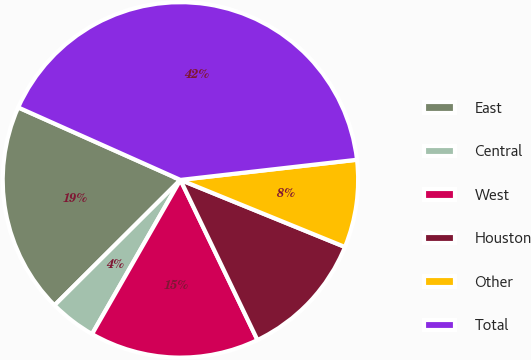<chart> <loc_0><loc_0><loc_500><loc_500><pie_chart><fcel>East<fcel>Central<fcel>West<fcel>Houston<fcel>Other<fcel>Total<nl><fcel>19.15%<fcel>4.25%<fcel>15.42%<fcel>11.7%<fcel>7.97%<fcel>41.5%<nl></chart> 